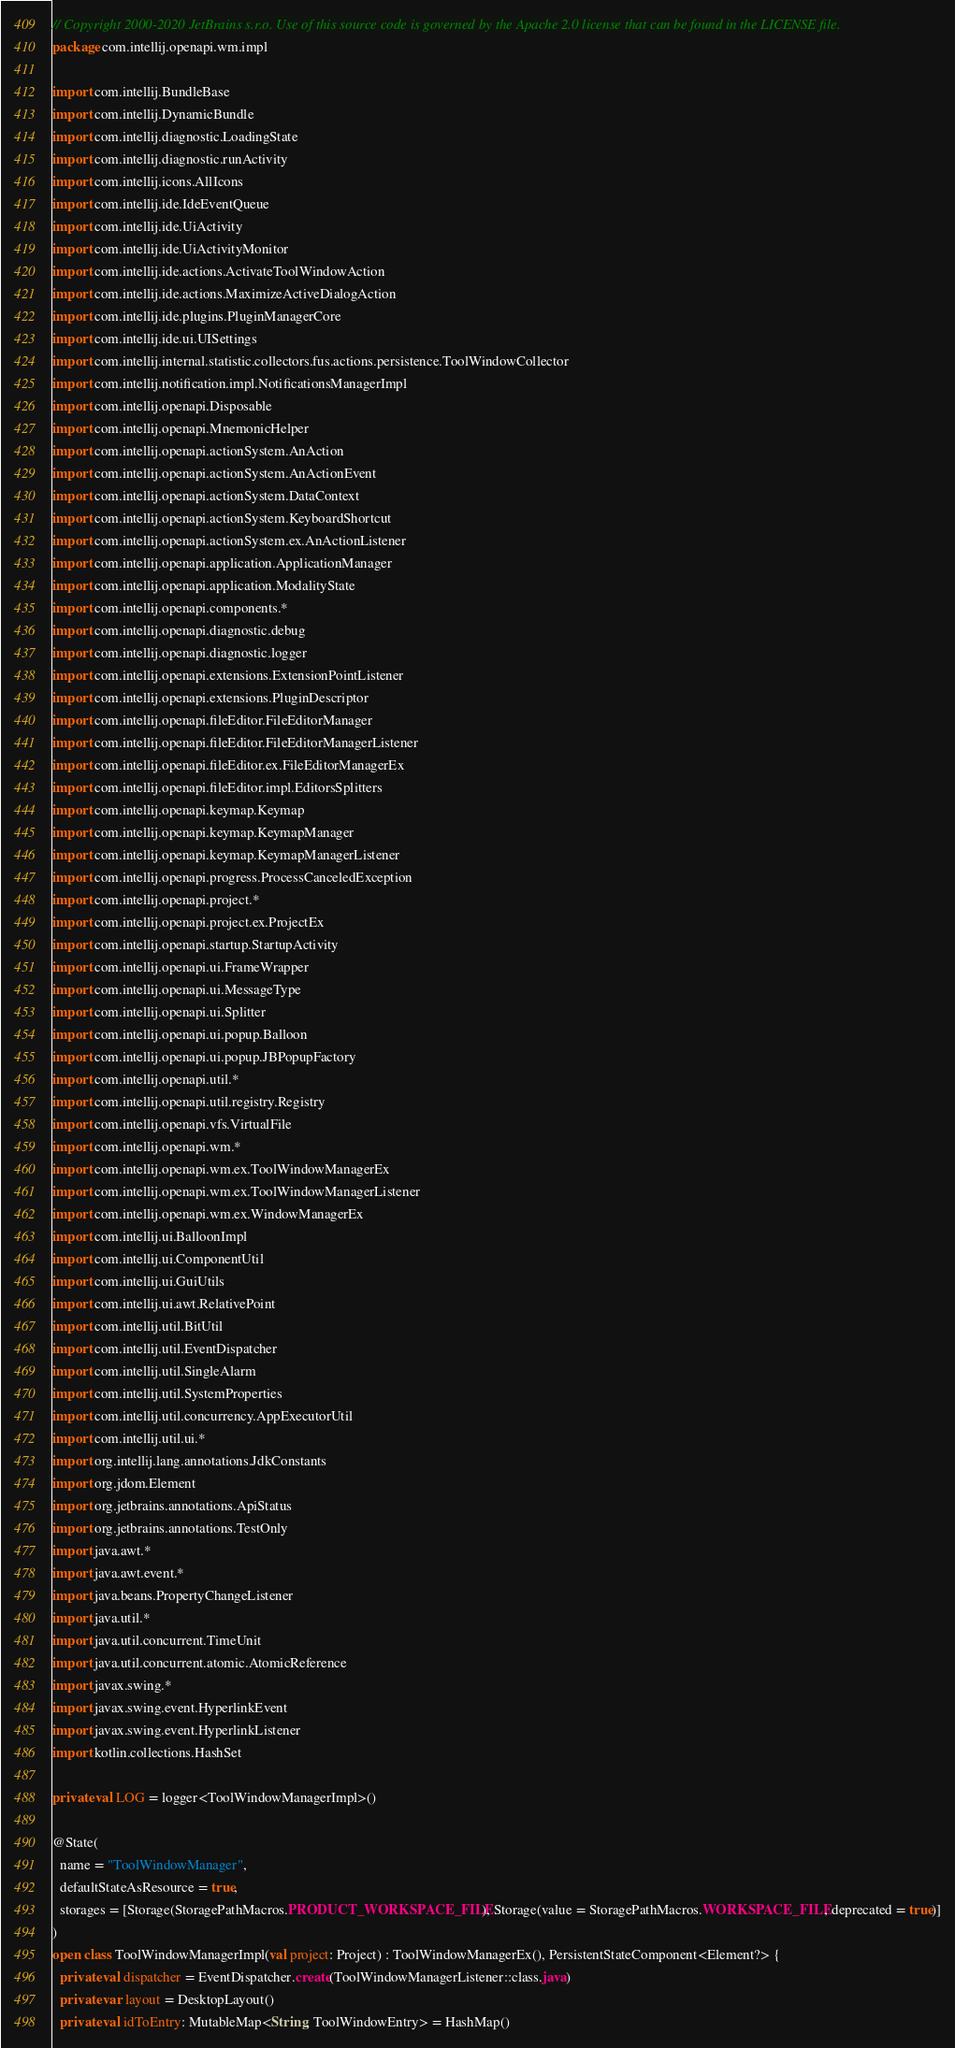<code> <loc_0><loc_0><loc_500><loc_500><_Kotlin_>// Copyright 2000-2020 JetBrains s.r.o. Use of this source code is governed by the Apache 2.0 license that can be found in the LICENSE file.
package com.intellij.openapi.wm.impl

import com.intellij.BundleBase
import com.intellij.DynamicBundle
import com.intellij.diagnostic.LoadingState
import com.intellij.diagnostic.runActivity
import com.intellij.icons.AllIcons
import com.intellij.ide.IdeEventQueue
import com.intellij.ide.UiActivity
import com.intellij.ide.UiActivityMonitor
import com.intellij.ide.actions.ActivateToolWindowAction
import com.intellij.ide.actions.MaximizeActiveDialogAction
import com.intellij.ide.plugins.PluginManagerCore
import com.intellij.ide.ui.UISettings
import com.intellij.internal.statistic.collectors.fus.actions.persistence.ToolWindowCollector
import com.intellij.notification.impl.NotificationsManagerImpl
import com.intellij.openapi.Disposable
import com.intellij.openapi.MnemonicHelper
import com.intellij.openapi.actionSystem.AnAction
import com.intellij.openapi.actionSystem.AnActionEvent
import com.intellij.openapi.actionSystem.DataContext
import com.intellij.openapi.actionSystem.KeyboardShortcut
import com.intellij.openapi.actionSystem.ex.AnActionListener
import com.intellij.openapi.application.ApplicationManager
import com.intellij.openapi.application.ModalityState
import com.intellij.openapi.components.*
import com.intellij.openapi.diagnostic.debug
import com.intellij.openapi.diagnostic.logger
import com.intellij.openapi.extensions.ExtensionPointListener
import com.intellij.openapi.extensions.PluginDescriptor
import com.intellij.openapi.fileEditor.FileEditorManager
import com.intellij.openapi.fileEditor.FileEditorManagerListener
import com.intellij.openapi.fileEditor.ex.FileEditorManagerEx
import com.intellij.openapi.fileEditor.impl.EditorsSplitters
import com.intellij.openapi.keymap.Keymap
import com.intellij.openapi.keymap.KeymapManager
import com.intellij.openapi.keymap.KeymapManagerListener
import com.intellij.openapi.progress.ProcessCanceledException
import com.intellij.openapi.project.*
import com.intellij.openapi.project.ex.ProjectEx
import com.intellij.openapi.startup.StartupActivity
import com.intellij.openapi.ui.FrameWrapper
import com.intellij.openapi.ui.MessageType
import com.intellij.openapi.ui.Splitter
import com.intellij.openapi.ui.popup.Balloon
import com.intellij.openapi.ui.popup.JBPopupFactory
import com.intellij.openapi.util.*
import com.intellij.openapi.util.registry.Registry
import com.intellij.openapi.vfs.VirtualFile
import com.intellij.openapi.wm.*
import com.intellij.openapi.wm.ex.ToolWindowManagerEx
import com.intellij.openapi.wm.ex.ToolWindowManagerListener
import com.intellij.openapi.wm.ex.WindowManagerEx
import com.intellij.ui.BalloonImpl
import com.intellij.ui.ComponentUtil
import com.intellij.ui.GuiUtils
import com.intellij.ui.awt.RelativePoint
import com.intellij.util.BitUtil
import com.intellij.util.EventDispatcher
import com.intellij.util.SingleAlarm
import com.intellij.util.SystemProperties
import com.intellij.util.concurrency.AppExecutorUtil
import com.intellij.util.ui.*
import org.intellij.lang.annotations.JdkConstants
import org.jdom.Element
import org.jetbrains.annotations.ApiStatus
import org.jetbrains.annotations.TestOnly
import java.awt.*
import java.awt.event.*
import java.beans.PropertyChangeListener
import java.util.*
import java.util.concurrent.TimeUnit
import java.util.concurrent.atomic.AtomicReference
import javax.swing.*
import javax.swing.event.HyperlinkEvent
import javax.swing.event.HyperlinkListener
import kotlin.collections.HashSet

private val LOG = logger<ToolWindowManagerImpl>()

@State(
  name = "ToolWindowManager",
  defaultStateAsResource = true,
  storages = [Storage(StoragePathMacros.PRODUCT_WORKSPACE_FILE), Storage(value = StoragePathMacros.WORKSPACE_FILE, deprecated = true)]
)
open class ToolWindowManagerImpl(val project: Project) : ToolWindowManagerEx(), PersistentStateComponent<Element?> {
  private val dispatcher = EventDispatcher.create(ToolWindowManagerListener::class.java)
  private var layout = DesktopLayout()
  private val idToEntry: MutableMap<String, ToolWindowEntry> = HashMap()</code> 